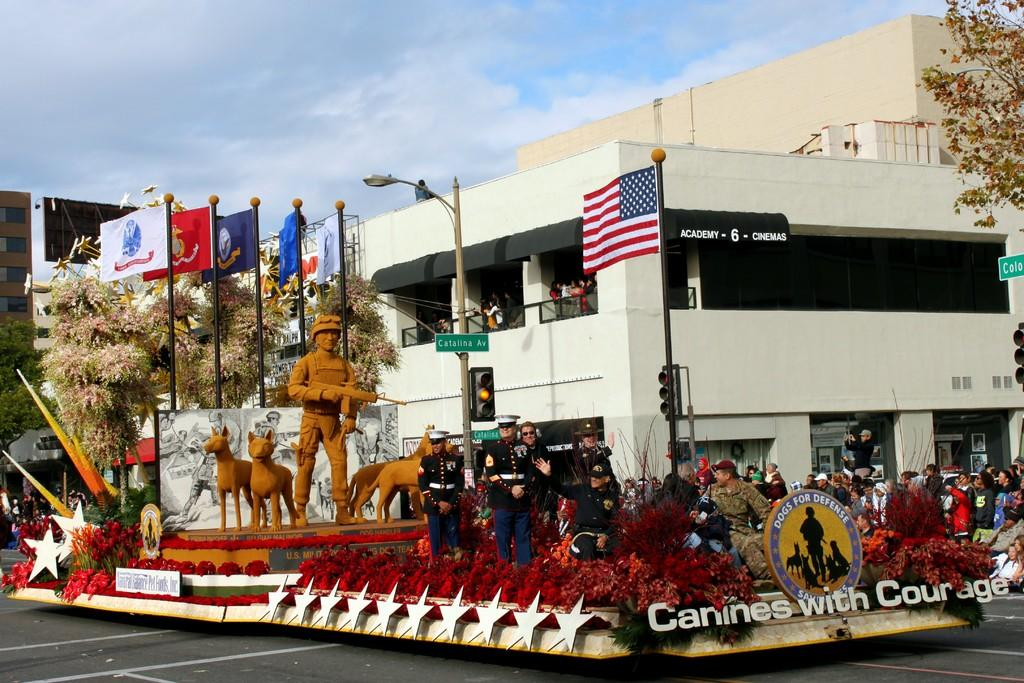<image>
Describe the image concisely. A parade float for an organization called Canines with Courage. 